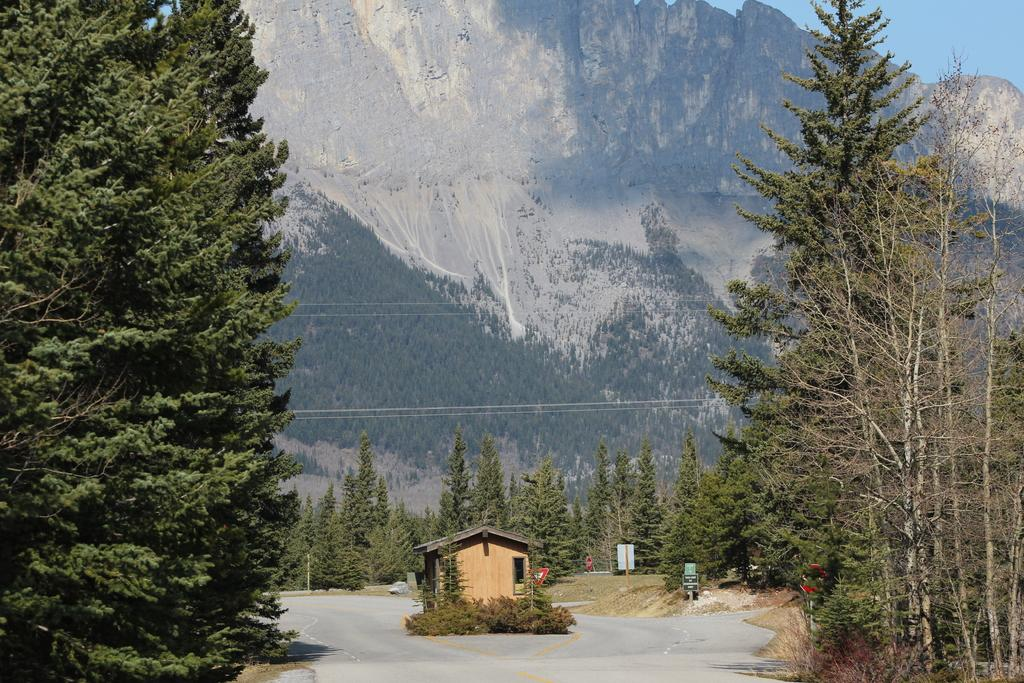What type of vegetation is present in the left corner of the image? There are trees in the left corner of the image. What type of vegetation is present in the right corner of the image? There are trees in the right corner of the image. What is located at the bottom of the image? There is a road at the bottom of the image. What type of structure is visible in the background of the image? There is a hut in the background of the image. What type of vegetation is present in the background of the image? There are trees in the background of the image. What type of geographical feature is visible in the background of the image? There are mountains in the background of the image. What is visible at the top of the image? The sky is visible at the top of the image. Can you tell me how many monkeys are sitting on the hut in the image? There are no monkeys present in the image; it features trees, a road, a hut, mountains, and the sky. Is the existence of a goat confirmed in the image? There is no goat present in the image. 